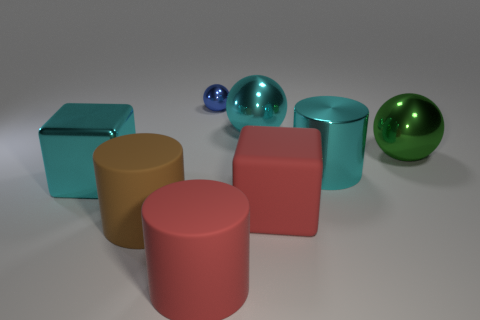Are there fewer large brown matte objects behind the large green sphere than blocks that are to the left of the blue metal sphere?
Your answer should be compact. Yes. There is a big cylinder that is right of the red cube; does it have the same color as the big shiny object behind the green metal thing?
Provide a short and direct response. Yes. Is there a red object made of the same material as the big green sphere?
Your answer should be very brief. No. How big is the red cube that is in front of the block that is behind the red matte cube?
Make the answer very short. Large. Is the number of gray cylinders greater than the number of large shiny cylinders?
Provide a short and direct response. No. There is a red matte thing that is in front of the red rubber block; does it have the same size as the big cyan metallic sphere?
Your response must be concise. Yes. What number of tiny objects have the same color as the large metallic cylinder?
Your answer should be compact. 0. Is the shape of the tiny shiny thing the same as the big brown rubber thing?
Keep it short and to the point. No. Is there any other thing that is the same size as the red block?
Your response must be concise. Yes. There is a red matte thing that is the same shape as the brown rubber thing; what is its size?
Give a very brief answer. Large. 